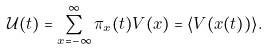Convert formula to latex. <formula><loc_0><loc_0><loc_500><loc_500>\mathcal { U } ( t ) = \sum ^ { \infty } _ { x = - \infty } \pi _ { x } ( t ) V ( x ) = \langle V ( x ( t ) ) \rangle .</formula> 